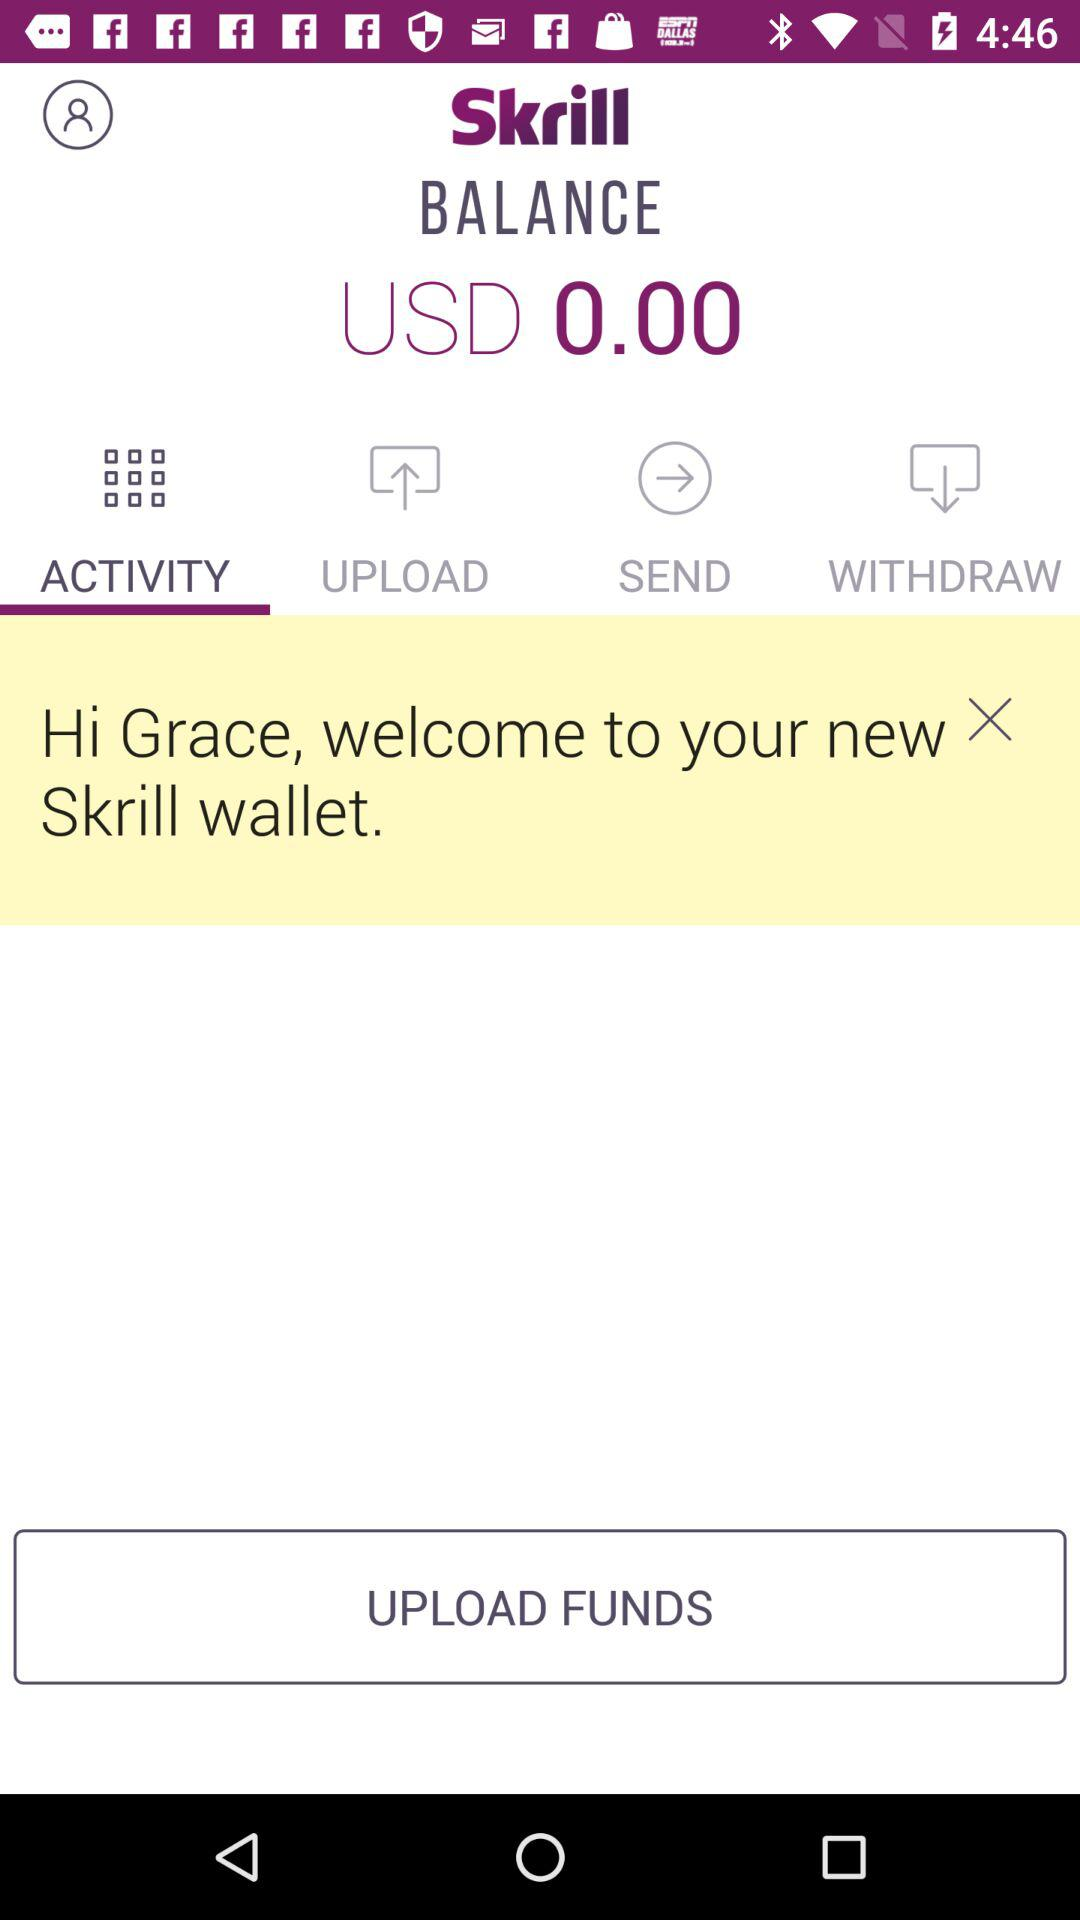What is the name of the user? The username is Grace. 